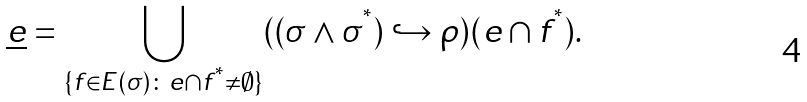<formula> <loc_0><loc_0><loc_500><loc_500>\underline { e } = \bigcup _ { \{ f \in E ( \sigma ) \colon e \cap f ^ { ^ { * } } \neq \emptyset \} } ( ( \sigma \land \sigma ^ { ^ { * } } ) \hookrightarrow \rho ) ( e \cap f ^ { ^ { * } } ) .</formula> 